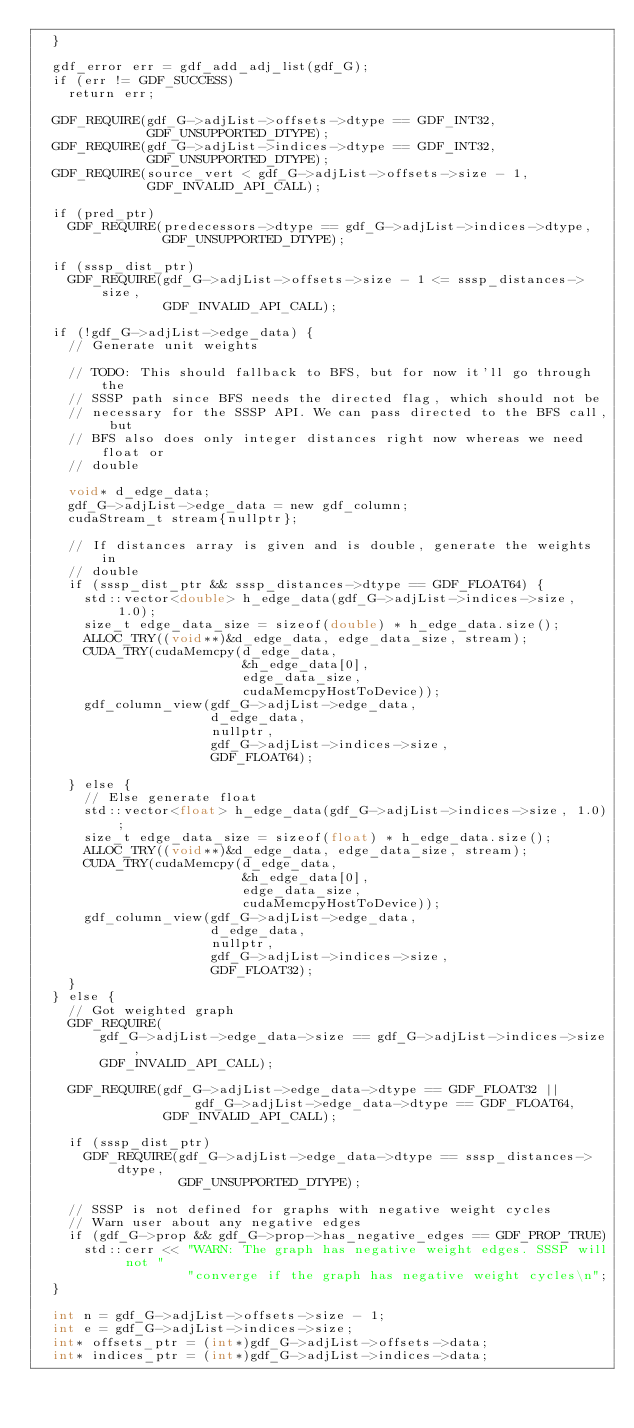<code> <loc_0><loc_0><loc_500><loc_500><_Cuda_>  }

  gdf_error err = gdf_add_adj_list(gdf_G);
  if (err != GDF_SUCCESS)
    return err;

  GDF_REQUIRE(gdf_G->adjList->offsets->dtype == GDF_INT32,
              GDF_UNSUPPORTED_DTYPE);
  GDF_REQUIRE(gdf_G->adjList->indices->dtype == GDF_INT32,
              GDF_UNSUPPORTED_DTYPE);
  GDF_REQUIRE(source_vert < gdf_G->adjList->offsets->size - 1,
              GDF_INVALID_API_CALL);

  if (pred_ptr)
    GDF_REQUIRE(predecessors->dtype == gdf_G->adjList->indices->dtype,
                GDF_UNSUPPORTED_DTYPE);

  if (sssp_dist_ptr)
    GDF_REQUIRE(gdf_G->adjList->offsets->size - 1 <= sssp_distances->size,
                GDF_INVALID_API_CALL);

  if (!gdf_G->adjList->edge_data) {
    // Generate unit weights

    // TODO: This should fallback to BFS, but for now it'll go through the
    // SSSP path since BFS needs the directed flag, which should not be
    // necessary for the SSSP API. We can pass directed to the BFS call, but
    // BFS also does only integer distances right now whereas we need float or
    // double

    void* d_edge_data;
    gdf_G->adjList->edge_data = new gdf_column;
    cudaStream_t stream{nullptr};

    // If distances array is given and is double, generate the weights in
    // double
    if (sssp_dist_ptr && sssp_distances->dtype == GDF_FLOAT64) {
      std::vector<double> h_edge_data(gdf_G->adjList->indices->size, 1.0);
      size_t edge_data_size = sizeof(double) * h_edge_data.size();
      ALLOC_TRY((void**)&d_edge_data, edge_data_size, stream);
      CUDA_TRY(cudaMemcpy(d_edge_data,
                          &h_edge_data[0],
                          edge_data_size,
                          cudaMemcpyHostToDevice));
      gdf_column_view(gdf_G->adjList->edge_data,
                      d_edge_data,
                      nullptr,
                      gdf_G->adjList->indices->size,
                      GDF_FLOAT64);

    } else {
      // Else generate float
      std::vector<float> h_edge_data(gdf_G->adjList->indices->size, 1.0);
      size_t edge_data_size = sizeof(float) * h_edge_data.size();
      ALLOC_TRY((void**)&d_edge_data, edge_data_size, stream);
      CUDA_TRY(cudaMemcpy(d_edge_data,
                          &h_edge_data[0],
                          edge_data_size,
                          cudaMemcpyHostToDevice));
      gdf_column_view(gdf_G->adjList->edge_data,
                      d_edge_data,
                      nullptr,
                      gdf_G->adjList->indices->size,
                      GDF_FLOAT32);
    }
  } else {
    // Got weighted graph
    GDF_REQUIRE(
        gdf_G->adjList->edge_data->size == gdf_G->adjList->indices->size,
        GDF_INVALID_API_CALL);

    GDF_REQUIRE(gdf_G->adjList->edge_data->dtype == GDF_FLOAT32 ||
                    gdf_G->adjList->edge_data->dtype == GDF_FLOAT64,
                GDF_INVALID_API_CALL);

    if (sssp_dist_ptr)
      GDF_REQUIRE(gdf_G->adjList->edge_data->dtype == sssp_distances->dtype,
                  GDF_UNSUPPORTED_DTYPE);

    // SSSP is not defined for graphs with negative weight cycles
    // Warn user about any negative edges
    if (gdf_G->prop && gdf_G->prop->has_negative_edges == GDF_PROP_TRUE)
      std::cerr << "WARN: The graph has negative weight edges. SSSP will not "
                   "converge if the graph has negative weight cycles\n";
  }

  int n = gdf_G->adjList->offsets->size - 1;
  int e = gdf_G->adjList->indices->size;
  int* offsets_ptr = (int*)gdf_G->adjList->offsets->data;
  int* indices_ptr = (int*)gdf_G->adjList->indices->data;
</code> 